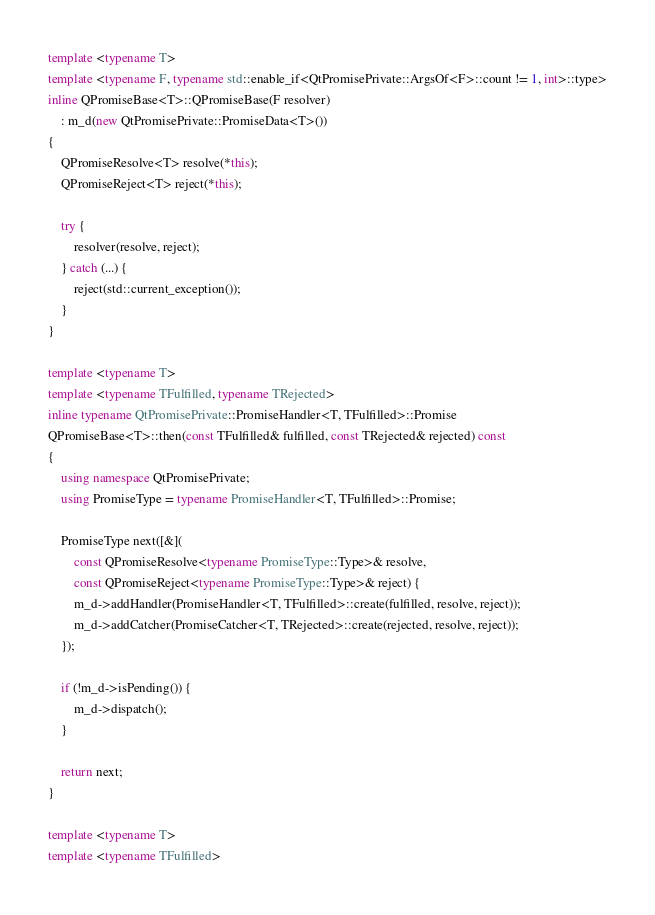<code> <loc_0><loc_0><loc_500><loc_500><_C++_>template <typename T>
template <typename F, typename std::enable_if<QtPromisePrivate::ArgsOf<F>::count != 1, int>::type>
inline QPromiseBase<T>::QPromiseBase(F resolver)
    : m_d(new QtPromisePrivate::PromiseData<T>())
{
    QPromiseResolve<T> resolve(*this);
    QPromiseReject<T> reject(*this);

    try {
        resolver(resolve, reject);
    } catch (...) {
        reject(std::current_exception());
    }
}

template <typename T>
template <typename TFulfilled, typename TRejected>
inline typename QtPromisePrivate::PromiseHandler<T, TFulfilled>::Promise
QPromiseBase<T>::then(const TFulfilled& fulfilled, const TRejected& rejected) const
{
    using namespace QtPromisePrivate;
    using PromiseType = typename PromiseHandler<T, TFulfilled>::Promise;

    PromiseType next([&](
        const QPromiseResolve<typename PromiseType::Type>& resolve,
        const QPromiseReject<typename PromiseType::Type>& reject) {
        m_d->addHandler(PromiseHandler<T, TFulfilled>::create(fulfilled, resolve, reject));
        m_d->addCatcher(PromiseCatcher<T, TRejected>::create(rejected, resolve, reject));
    });

    if (!m_d->isPending()) {
        m_d->dispatch();
    }

    return next;
}

template <typename T>
template <typename TFulfilled></code> 